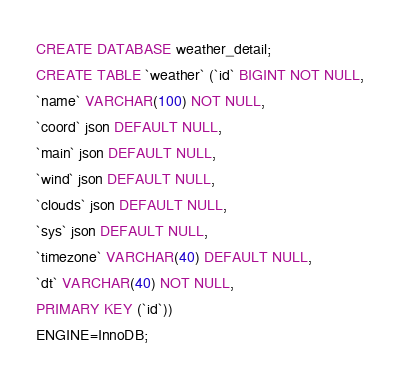Convert code to text. <code><loc_0><loc_0><loc_500><loc_500><_SQL_>CREATE DATABASE weather_detail;
CREATE TABLE `weather` (`id` BIGINT NOT NULL,
`name` VARCHAR(100) NOT NULL,
`coord` json DEFAULT NULL,
`main` json DEFAULT NULL,
`wind` json DEFAULT NULL,
`clouds` json DEFAULT NULL,
`sys` json DEFAULT NULL,
`timezone` VARCHAR(40) DEFAULT NULL,
`dt` VARCHAR(40) NOT NULL,
PRIMARY KEY (`id`))
ENGINE=InnoDB;
</code> 